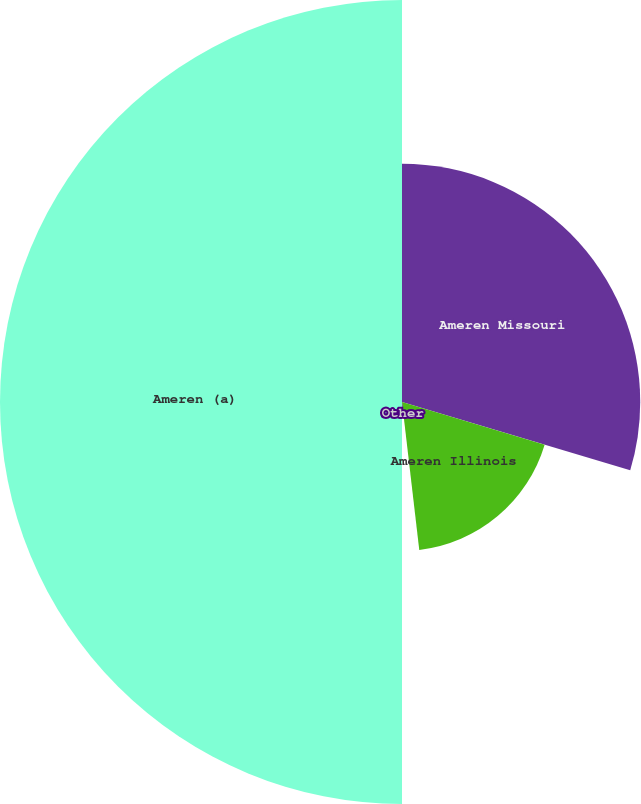Convert chart. <chart><loc_0><loc_0><loc_500><loc_500><pie_chart><fcel>Ameren Missouri<fcel>Ameren Illinois<fcel>Other<fcel>Ameren (a)<nl><fcel>29.63%<fcel>18.52%<fcel>1.85%<fcel>50.0%<nl></chart> 